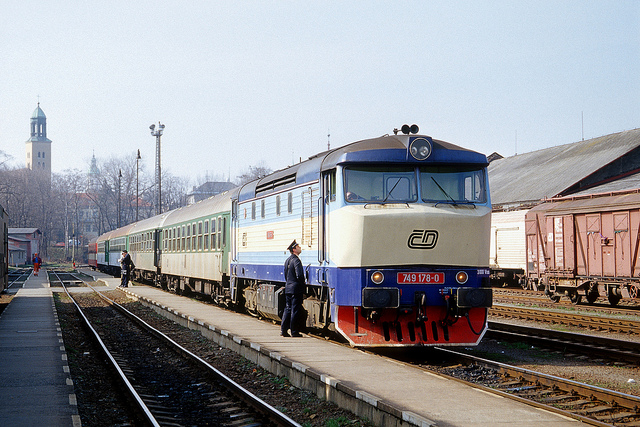Identify the text contained in this image. 749178-0 